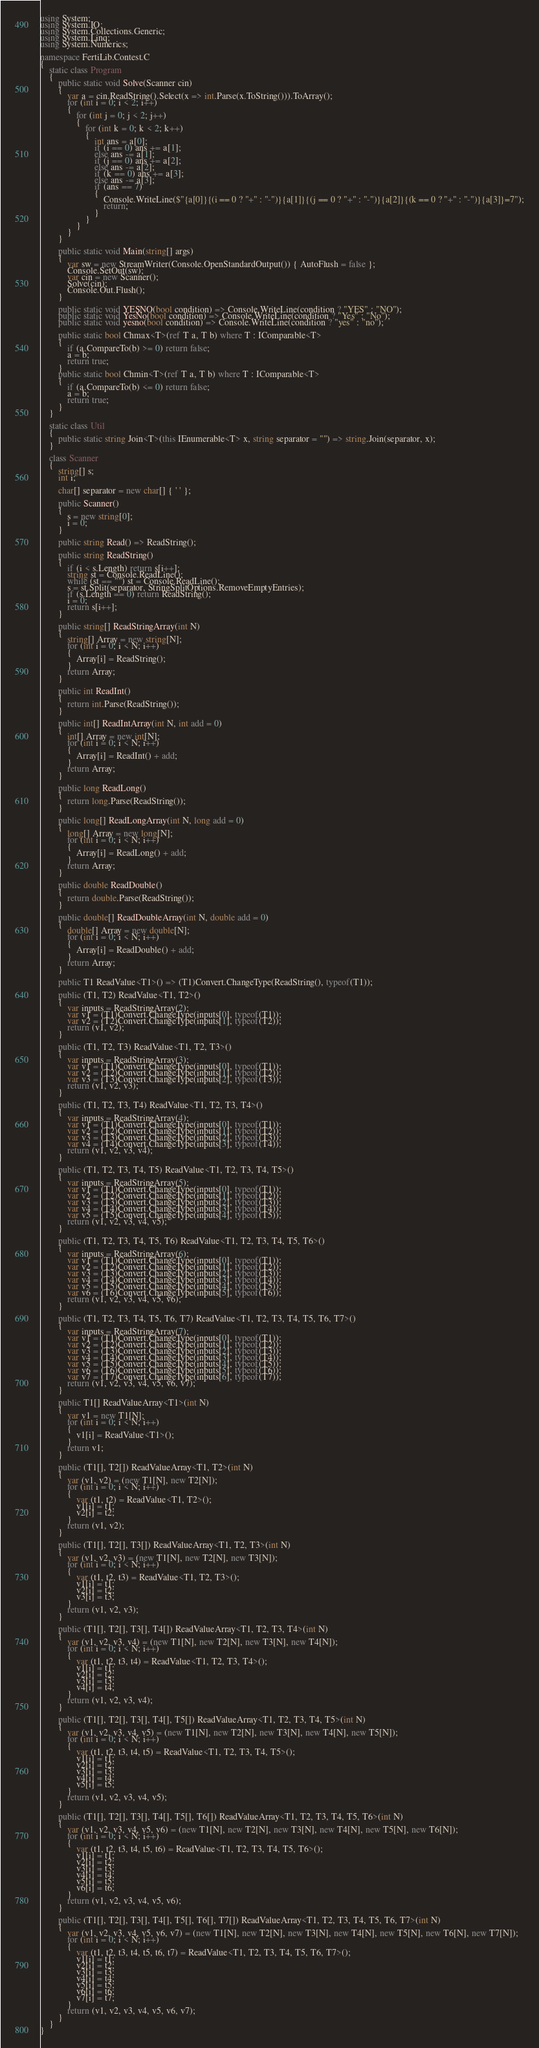<code> <loc_0><loc_0><loc_500><loc_500><_C#_>using System;
using System.IO;
using System.Collections.Generic;
using System.Linq;
using System.Numerics;

namespace FertiLib.Contest.C
{
	static class Program
	{
		public static void Solve(Scanner cin)
		{
			var a = cin.ReadString().Select(x => int.Parse(x.ToString())).ToArray();
			for (int i = 0; i < 2; i++)
			{
				for (int j = 0; j < 2; j++)
				{
					for (int k = 0; k < 2; k++)
					{
						int ans = a[0];
						if (i == 0) ans += a[1];
						else ans -= a[1];
						if (j == 0) ans += a[2];
						else ans -= a[2];
						if (k == 0) ans += a[3];
						else ans -= a[3];
						if (ans == 7)
						{
							Console.WriteLine($"{a[0]}{(i == 0 ? "+" : "-")}{a[1]}{(j == 0 ? "+" : "-")}{a[2]}{(k == 0 ? "+" : "-")}{a[3]}=7");
							return;
						}
					}
				}
			}
		}

		public static void Main(string[] args)
		{
			var sw = new StreamWriter(Console.OpenStandardOutput()) { AutoFlush = false };
			Console.SetOut(sw);
			var cin = new Scanner();
			Solve(cin);
			Console.Out.Flush();
		}

		public static void YESNO(bool condition) => Console.WriteLine(condition ? "YES" : "NO");
		public static void YesNo(bool condition) => Console.WriteLine(condition ? "Yes" : "No");
		public static void yesno(bool condition) => Console.WriteLine(condition ? "yes" : "no");

		public static bool Chmax<T>(ref T a, T b) where T : IComparable<T>
		{
			if (a.CompareTo(b) >= 0) return false;
			a = b;
			return true;
		}
		public static bool Chmin<T>(ref T a, T b) where T : IComparable<T>
		{
			if (a.CompareTo(b) <= 0) return false;
			a = b;
			return true;
		}
	}

	static class Util
	{
		public static string Join<T>(this IEnumerable<T> x, string separator = "") => string.Join(separator, x);
	}

	class Scanner
	{
		string[] s;
		int i;

		char[] separator = new char[] { ' ' };

		public Scanner()
		{
			s = new string[0];
			i = 0;
		}

		public string Read() => ReadString();

		public string ReadString()
		{
			if (i < s.Length) return s[i++];
			string st = Console.ReadLine();
			while (st == "") st = Console.ReadLine();
			s = st.Split(separator, StringSplitOptions.RemoveEmptyEntries);
			if (s.Length == 0) return ReadString();
			i = 0;
			return s[i++];
		}

		public string[] ReadStringArray(int N)
		{
			string[] Array = new string[N];
			for (int i = 0; i < N; i++)
			{
				Array[i] = ReadString();
			}
			return Array;
		}

		public int ReadInt()
		{
			return int.Parse(ReadString());
		}

		public int[] ReadIntArray(int N, int add = 0)
		{
			int[] Array = new int[N];
			for (int i = 0; i < N; i++)
			{
				Array[i] = ReadInt() + add;
			}
			return Array;
		}

		public long ReadLong()
		{
			return long.Parse(ReadString());
		}

		public long[] ReadLongArray(int N, long add = 0)
		{
			long[] Array = new long[N];
			for (int i = 0; i < N; i++)
			{
				Array[i] = ReadLong() + add;
			}
			return Array;
		}

		public double ReadDouble()
		{
			return double.Parse(ReadString());
		}

		public double[] ReadDoubleArray(int N, double add = 0)
		{
			double[] Array = new double[N];
			for (int i = 0; i < N; i++)
			{
				Array[i] = ReadDouble() + add;
			}
			return Array;
		}

		public T1 ReadValue<T1>() => (T1)Convert.ChangeType(ReadString(), typeof(T1));

		public (T1, T2) ReadValue<T1, T2>()
		{
			var inputs = ReadStringArray(2);
			var v1 = (T1)Convert.ChangeType(inputs[0], typeof(T1));
			var v2 = (T2)Convert.ChangeType(inputs[1], typeof(T2));
			return (v1, v2);
		}

		public (T1, T2, T3) ReadValue<T1, T2, T3>()
		{
			var inputs = ReadStringArray(3);
			var v1 = (T1)Convert.ChangeType(inputs[0], typeof(T1));
			var v2 = (T2)Convert.ChangeType(inputs[1], typeof(T2));
			var v3 = (T3)Convert.ChangeType(inputs[2], typeof(T3));
			return (v1, v2, v3);
		}

		public (T1, T2, T3, T4) ReadValue<T1, T2, T3, T4>()
		{
			var inputs = ReadStringArray(4);
			var v1 = (T1)Convert.ChangeType(inputs[0], typeof(T1));
			var v2 = (T2)Convert.ChangeType(inputs[1], typeof(T2));
			var v3 = (T3)Convert.ChangeType(inputs[2], typeof(T3));
			var v4 = (T4)Convert.ChangeType(inputs[3], typeof(T4));
			return (v1, v2, v3, v4);
		}

		public (T1, T2, T3, T4, T5) ReadValue<T1, T2, T3, T4, T5>()
		{
			var inputs = ReadStringArray(5);
			var v1 = (T1)Convert.ChangeType(inputs[0], typeof(T1));
			var v2 = (T2)Convert.ChangeType(inputs[1], typeof(T2));
			var v3 = (T3)Convert.ChangeType(inputs[2], typeof(T3));
			var v4 = (T4)Convert.ChangeType(inputs[3], typeof(T4));
			var v5 = (T5)Convert.ChangeType(inputs[4], typeof(T5));
			return (v1, v2, v3, v4, v5);
		}

		public (T1, T2, T3, T4, T5, T6) ReadValue<T1, T2, T3, T4, T5, T6>()
		{
			var inputs = ReadStringArray(6);
			var v1 = (T1)Convert.ChangeType(inputs[0], typeof(T1));
			var v2 = (T2)Convert.ChangeType(inputs[1], typeof(T2));
			var v3 = (T3)Convert.ChangeType(inputs[2], typeof(T3));
			var v4 = (T4)Convert.ChangeType(inputs[3], typeof(T4));
			var v5 = (T5)Convert.ChangeType(inputs[4], typeof(T5));
			var v6 = (T6)Convert.ChangeType(inputs[5], typeof(T6));
			return (v1, v2, v3, v4, v5, v6);
		}

		public (T1, T2, T3, T4, T5, T6, T7) ReadValue<T1, T2, T3, T4, T5, T6, T7>()
		{
			var inputs = ReadStringArray(7);
			var v1 = (T1)Convert.ChangeType(inputs[0], typeof(T1));
			var v2 = (T2)Convert.ChangeType(inputs[1], typeof(T2));
			var v3 = (T3)Convert.ChangeType(inputs[2], typeof(T3));
			var v4 = (T4)Convert.ChangeType(inputs[3], typeof(T4));
			var v5 = (T5)Convert.ChangeType(inputs[4], typeof(T5));
			var v6 = (T6)Convert.ChangeType(inputs[5], typeof(T6));
			var v7 = (T7)Convert.ChangeType(inputs[6], typeof(T7));
			return (v1, v2, v3, v4, v5, v6, v7);
		}

		public T1[] ReadValueArray<T1>(int N)
		{
			var v1 = new T1[N];
			for (int i = 0; i < N; i++)
			{
				v1[i] = ReadValue<T1>();
			}
			return v1;
		}

		public (T1[], T2[]) ReadValueArray<T1, T2>(int N)
		{
			var (v1, v2) = (new T1[N], new T2[N]);
			for (int i = 0; i < N; i++)
			{
				var (t1, t2) = ReadValue<T1, T2>();
				v1[i] = t1;
				v2[i] = t2;
			}
			return (v1, v2);
		}

		public (T1[], T2[], T3[]) ReadValueArray<T1, T2, T3>(int N)
		{
			var (v1, v2, v3) = (new T1[N], new T2[N], new T3[N]);
			for (int i = 0; i < N; i++)
			{
				var (t1, t2, t3) = ReadValue<T1, T2, T3>();
				v1[i] = t1;
				v2[i] = t2;
				v3[i] = t3;
			}
			return (v1, v2, v3);
		}

		public (T1[], T2[], T3[], T4[]) ReadValueArray<T1, T2, T3, T4>(int N)
		{
			var (v1, v2, v3, v4) = (new T1[N], new T2[N], new T3[N], new T4[N]);
			for (int i = 0; i < N; i++)
			{
				var (t1, t2, t3, t4) = ReadValue<T1, T2, T3, T4>();
				v1[i] = t1;
				v2[i] = t2;
				v3[i] = t3;
				v4[i] = t4;
			}
			return (v1, v2, v3, v4);
		}

		public (T1[], T2[], T3[], T4[], T5[]) ReadValueArray<T1, T2, T3, T4, T5>(int N)
		{
			var (v1, v2, v3, v4, v5) = (new T1[N], new T2[N], new T3[N], new T4[N], new T5[N]);
			for (int i = 0; i < N; i++)
			{
				var (t1, t2, t3, t4, t5) = ReadValue<T1, T2, T3, T4, T5>();
				v1[i] = t1;
				v2[i] = t2;
				v3[i] = t3;
				v4[i] = t4;
				v5[i] = t5;
			}
			return (v1, v2, v3, v4, v5);
		}

		public (T1[], T2[], T3[], T4[], T5[], T6[]) ReadValueArray<T1, T2, T3, T4, T5, T6>(int N)
		{
			var (v1, v2, v3, v4, v5, v6) = (new T1[N], new T2[N], new T3[N], new T4[N], new T5[N], new T6[N]);
			for (int i = 0; i < N; i++)
			{
				var (t1, t2, t3, t4, t5, t6) = ReadValue<T1, T2, T3, T4, T5, T6>();
				v1[i] = t1;
				v2[i] = t2;
				v3[i] = t3;
				v4[i] = t4;
				v5[i] = t5;
				v6[i] = t6;
			}
			return (v1, v2, v3, v4, v5, v6);
		}

		public (T1[], T2[], T3[], T4[], T5[], T6[], T7[]) ReadValueArray<T1, T2, T3, T4, T5, T6, T7>(int N)
		{
			var (v1, v2, v3, v4, v5, v6, v7) = (new T1[N], new T2[N], new T3[N], new T4[N], new T5[N], new T6[N], new T7[N]);
			for (int i = 0; i < N; i++)
			{
				var (t1, t2, t3, t4, t5, t6, t7) = ReadValue<T1, T2, T3, T4, T5, T6, T7>();
				v1[i] = t1;
				v2[i] = t2;
				v3[i] = t3;
				v4[i] = t4;
				v5[i] = t5;
				v6[i] = t6;
				v7[i] = t7;
			}
			return (v1, v2, v3, v4, v5, v6, v7);
		}
	}
}
</code> 